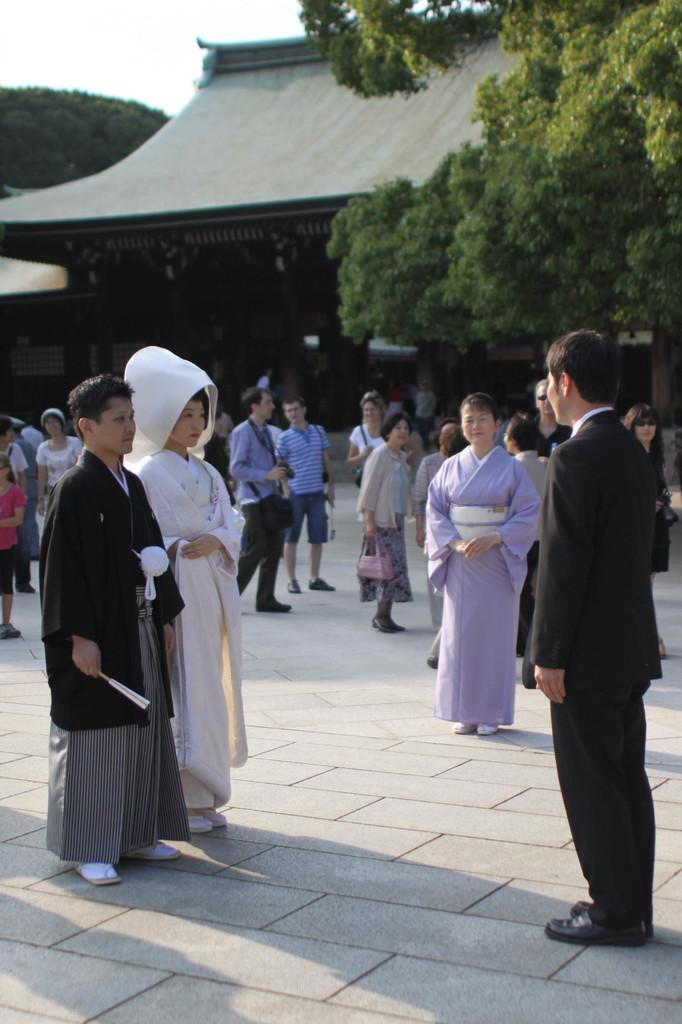Where was the image taken? The image was taken outside. What can be seen in the foreground of the image? There is a group of people standing in the foreground. What is the surface the people are standing on? The people are standing on the ground. What is visible in the background of the image? There is a sky, a house, and trees visible in the background. What type of floor can be seen in the image? There is no floor visible in the image, as the people are standing on the ground outside. 